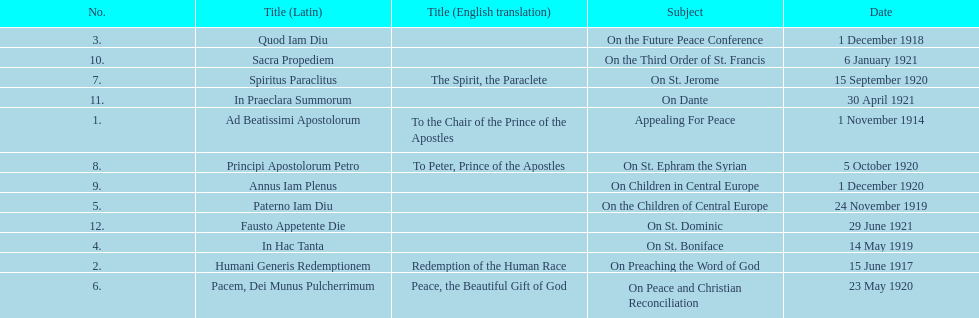How long after quod iam diu was paterno iam diu issued? 11 months. 